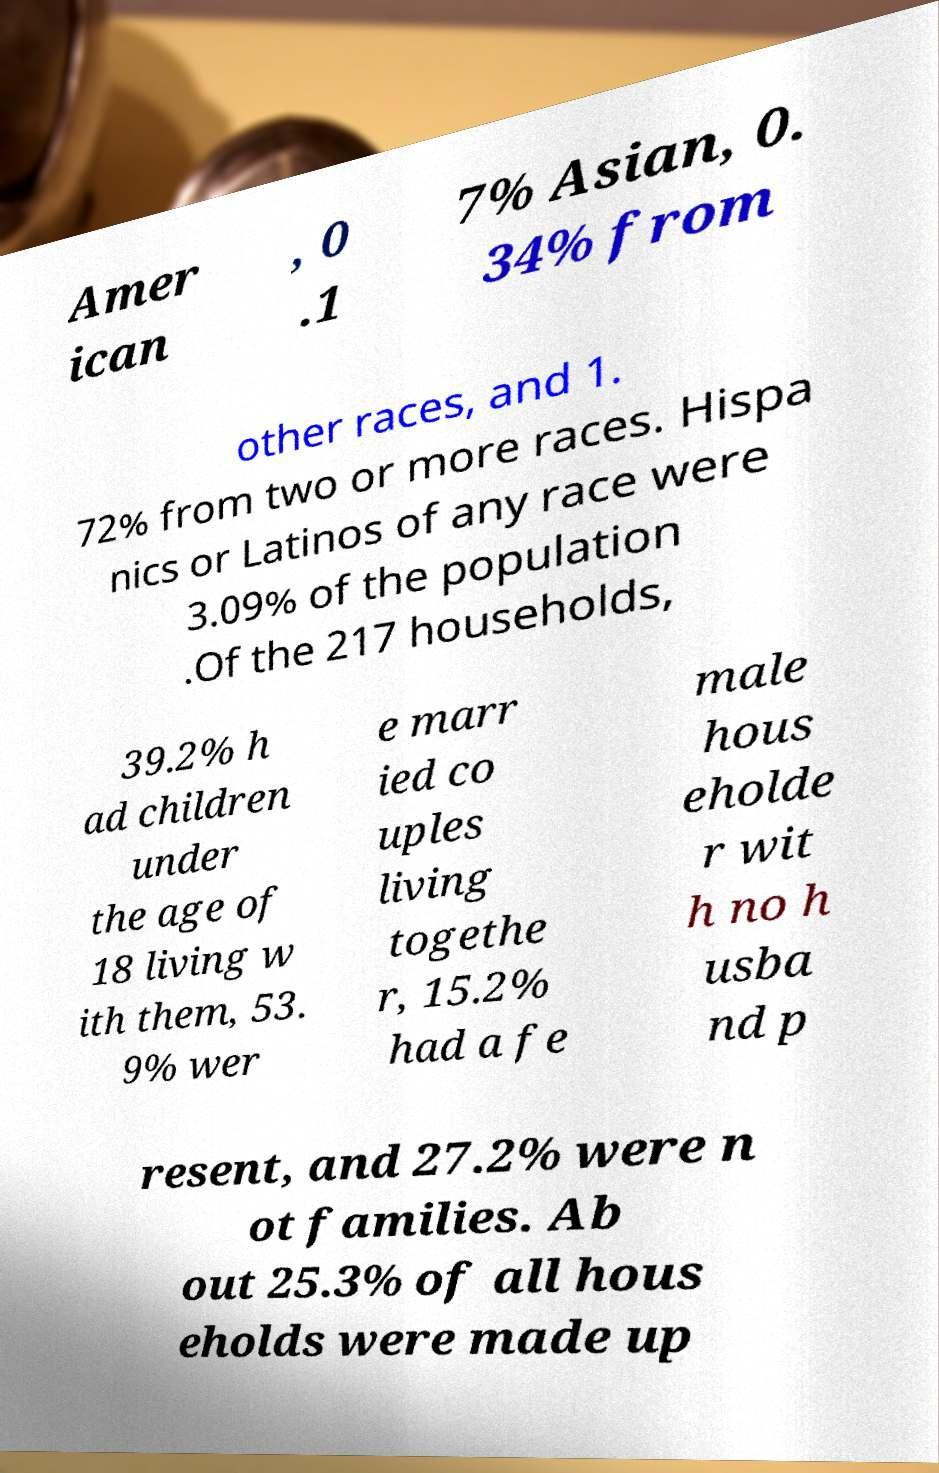Could you extract and type out the text from this image? Amer ican , 0 .1 7% Asian, 0. 34% from other races, and 1. 72% from two or more races. Hispa nics or Latinos of any race were 3.09% of the population .Of the 217 households, 39.2% h ad children under the age of 18 living w ith them, 53. 9% wer e marr ied co uples living togethe r, 15.2% had a fe male hous eholde r wit h no h usba nd p resent, and 27.2% were n ot families. Ab out 25.3% of all hous eholds were made up 